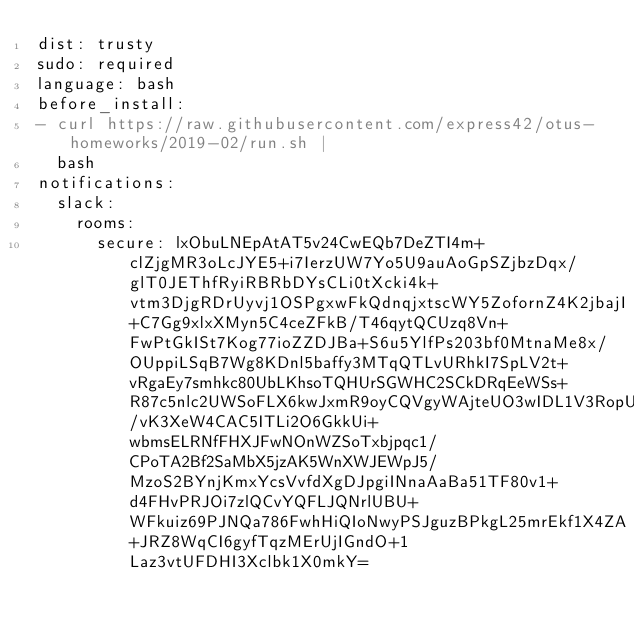Convert code to text. <code><loc_0><loc_0><loc_500><loc_500><_YAML_>dist: trusty
sudo: required
language: bash
before_install:
- curl https://raw.githubusercontent.com/express42/otus-homeworks/2019-02/run.sh |
  bash
notifications:
  slack:
    rooms:
      secure: lxObuLNEpAtAT5v24CwEQb7DeZTI4m+clZjgMR3oLcJYE5+i7IerzUW7Yo5U9auAoGpSZjbzDqx/glT0JEThfRyiRBRbDYsCLi0tXcki4k+vtm3DjgRDrUyvj1OSPgxwFkQdnqjxtscWY5ZofornZ4K2jbajI+C7Gg9xlxXMyn5C4ceZFkB/T46qytQCUzq8Vn+FwPtGkISt7Kog77ioZZDJBa+S6u5YlfPs203bf0MtnaMe8x/OUppiLSqB7Wg8KDnl5baffy3MTqQTLvURhkI7SpLV2t+vRgaEy7smhkc80UbLKhsoTQHUrSGWHC2SCkDRqEeWSs+R87c5nlc2UWSoFLX6kwJxmR9oyCQVgyWAjteUO3wIDL1V3RopU8vQU547egL5cuUoaZ2aNXjLVHukVIuS1PniSE0yNUa/vK3XeW4CAC5ITLi2O6GkkUi+wbmsELRNfFHXJFwNOnWZSoTxbjpqc1/CPoTA2Bf2SaMbX5jzAK5WnXWJEWpJ5/MzoS2BYnjKmxYcsVvfdXgDJpgiINnaAaBa51TF80v1+d4FHvPRJOi7zlQCvYQFLJQNrlUBU+WFkuiz69PJNQa786FwhHiQIoNwyPSJguzBPkgL25mrEkf1X4ZA+JRZ8WqCI6gyfTqzMErUjIGndO+1Laz3vtUFDHI3Xclbk1X0mkY=
</code> 